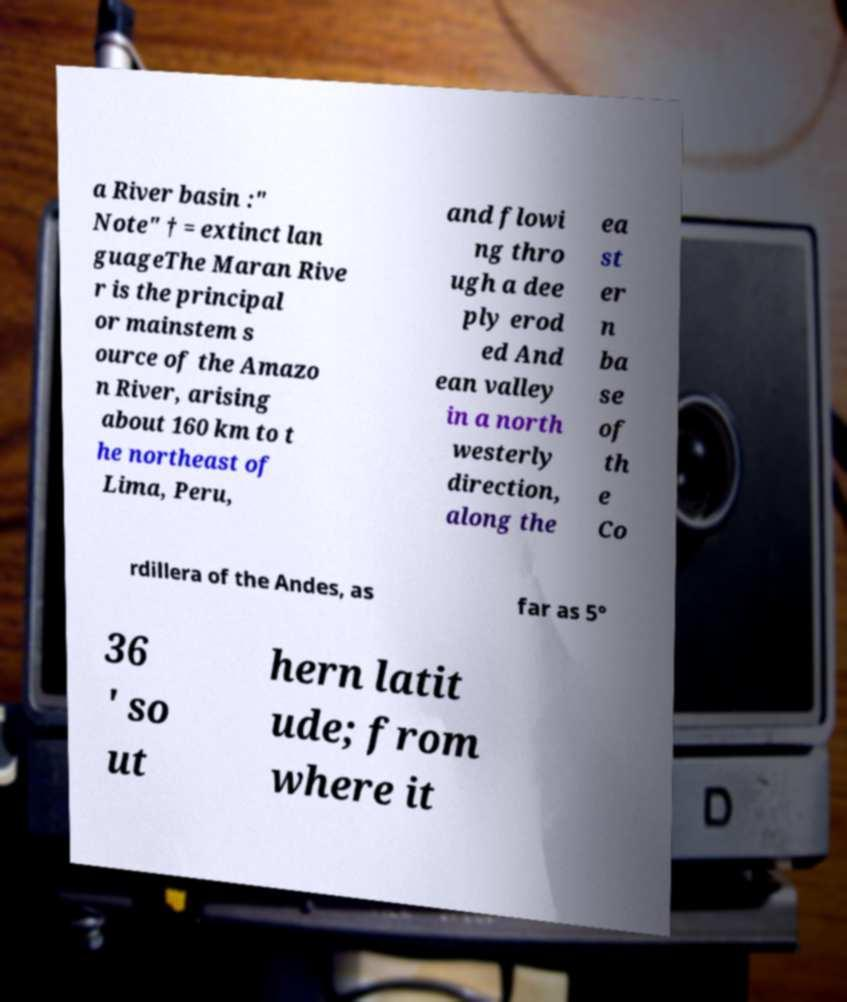What messages or text are displayed in this image? I need them in a readable, typed format. a River basin :" Note" † = extinct lan guageThe Maran Rive r is the principal or mainstem s ource of the Amazo n River, arising about 160 km to t he northeast of Lima, Peru, and flowi ng thro ugh a dee ply erod ed And ean valley in a north westerly direction, along the ea st er n ba se of th e Co rdillera of the Andes, as far as 5° 36 ′ so ut hern latit ude; from where it 